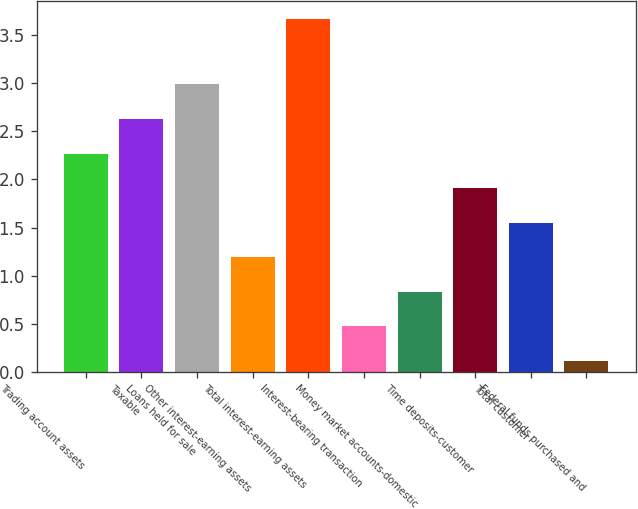Convert chart. <chart><loc_0><loc_0><loc_500><loc_500><bar_chart><fcel>Trading account assets<fcel>Taxable<fcel>Loans held for sale<fcel>Other interest-earning assets<fcel>Total interest-earning assets<fcel>Interest-bearing transaction<fcel>Money market accounts-domestic<fcel>Time deposits-customer<fcel>Total customer<fcel>Federal funds purchased and<nl><fcel>2.27<fcel>2.63<fcel>2.99<fcel>1.19<fcel>3.67<fcel>0.47<fcel>0.83<fcel>1.91<fcel>1.55<fcel>0.11<nl></chart> 